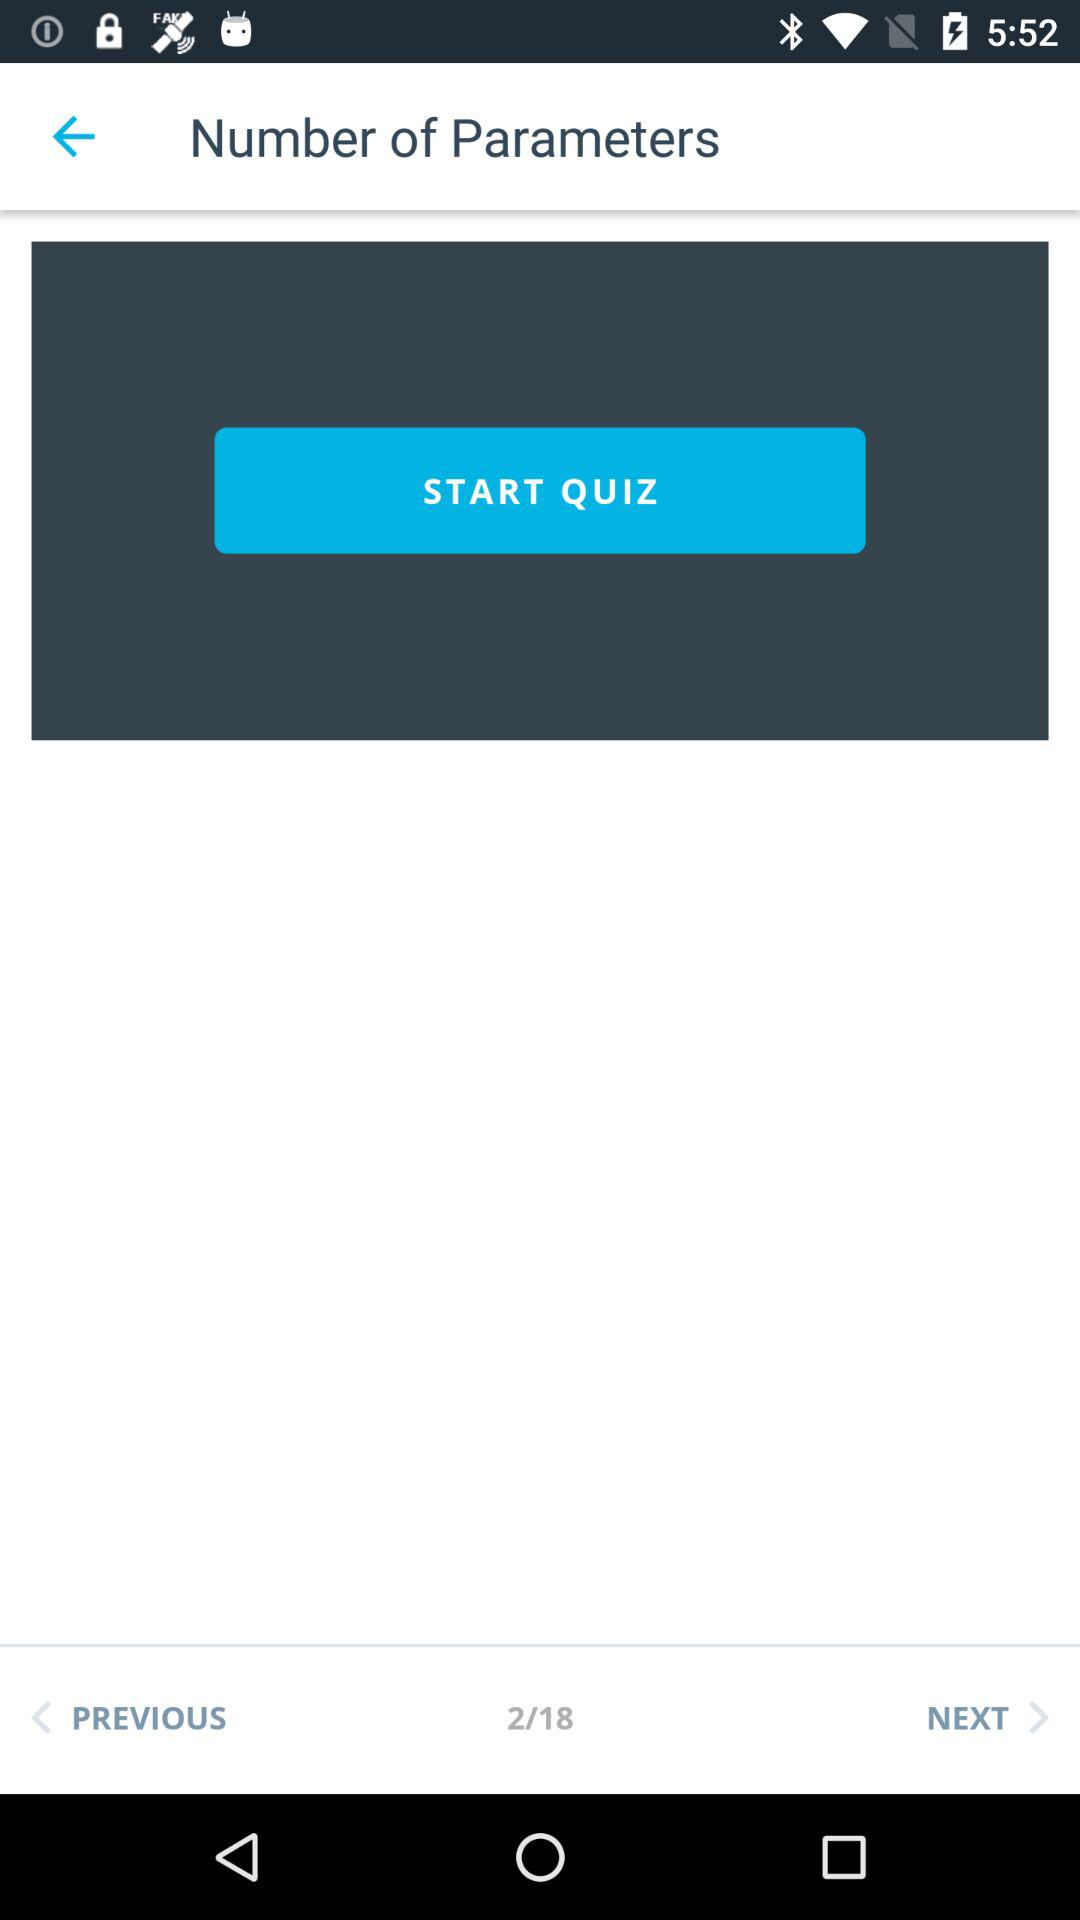What is the total number of given pages? The total number of pages is 18. 